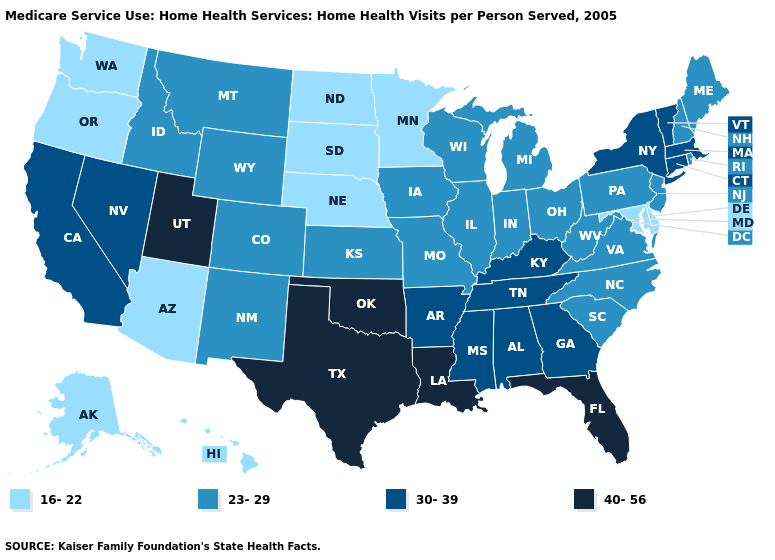How many symbols are there in the legend?
Give a very brief answer. 4. Does Mississippi have a lower value than Wyoming?
Keep it brief. No. What is the value of Hawaii?
Quick response, please. 16-22. Does South Carolina have a higher value than Nebraska?
Be succinct. Yes. Which states have the lowest value in the West?
Concise answer only. Alaska, Arizona, Hawaii, Oregon, Washington. Which states have the lowest value in the USA?
Short answer required. Alaska, Arizona, Delaware, Hawaii, Maryland, Minnesota, Nebraska, North Dakota, Oregon, South Dakota, Washington. Does Maryland have the lowest value in the USA?
Keep it brief. Yes. Among the states that border Georgia , does North Carolina have the lowest value?
Answer briefly. Yes. Among the states that border Wyoming , does South Dakota have the lowest value?
Keep it brief. Yes. Does Arizona have the highest value in the West?
Keep it brief. No. Name the states that have a value in the range 30-39?
Concise answer only. Alabama, Arkansas, California, Connecticut, Georgia, Kentucky, Massachusetts, Mississippi, Nevada, New York, Tennessee, Vermont. What is the value of Idaho?
Be succinct. 23-29. Does the map have missing data?
Write a very short answer. No. What is the value of North Dakota?
Keep it brief. 16-22. What is the lowest value in states that border Florida?
Keep it brief. 30-39. 